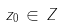Convert formula to latex. <formula><loc_0><loc_0><loc_500><loc_500>z _ { 0 } \, \in \, Z</formula> 